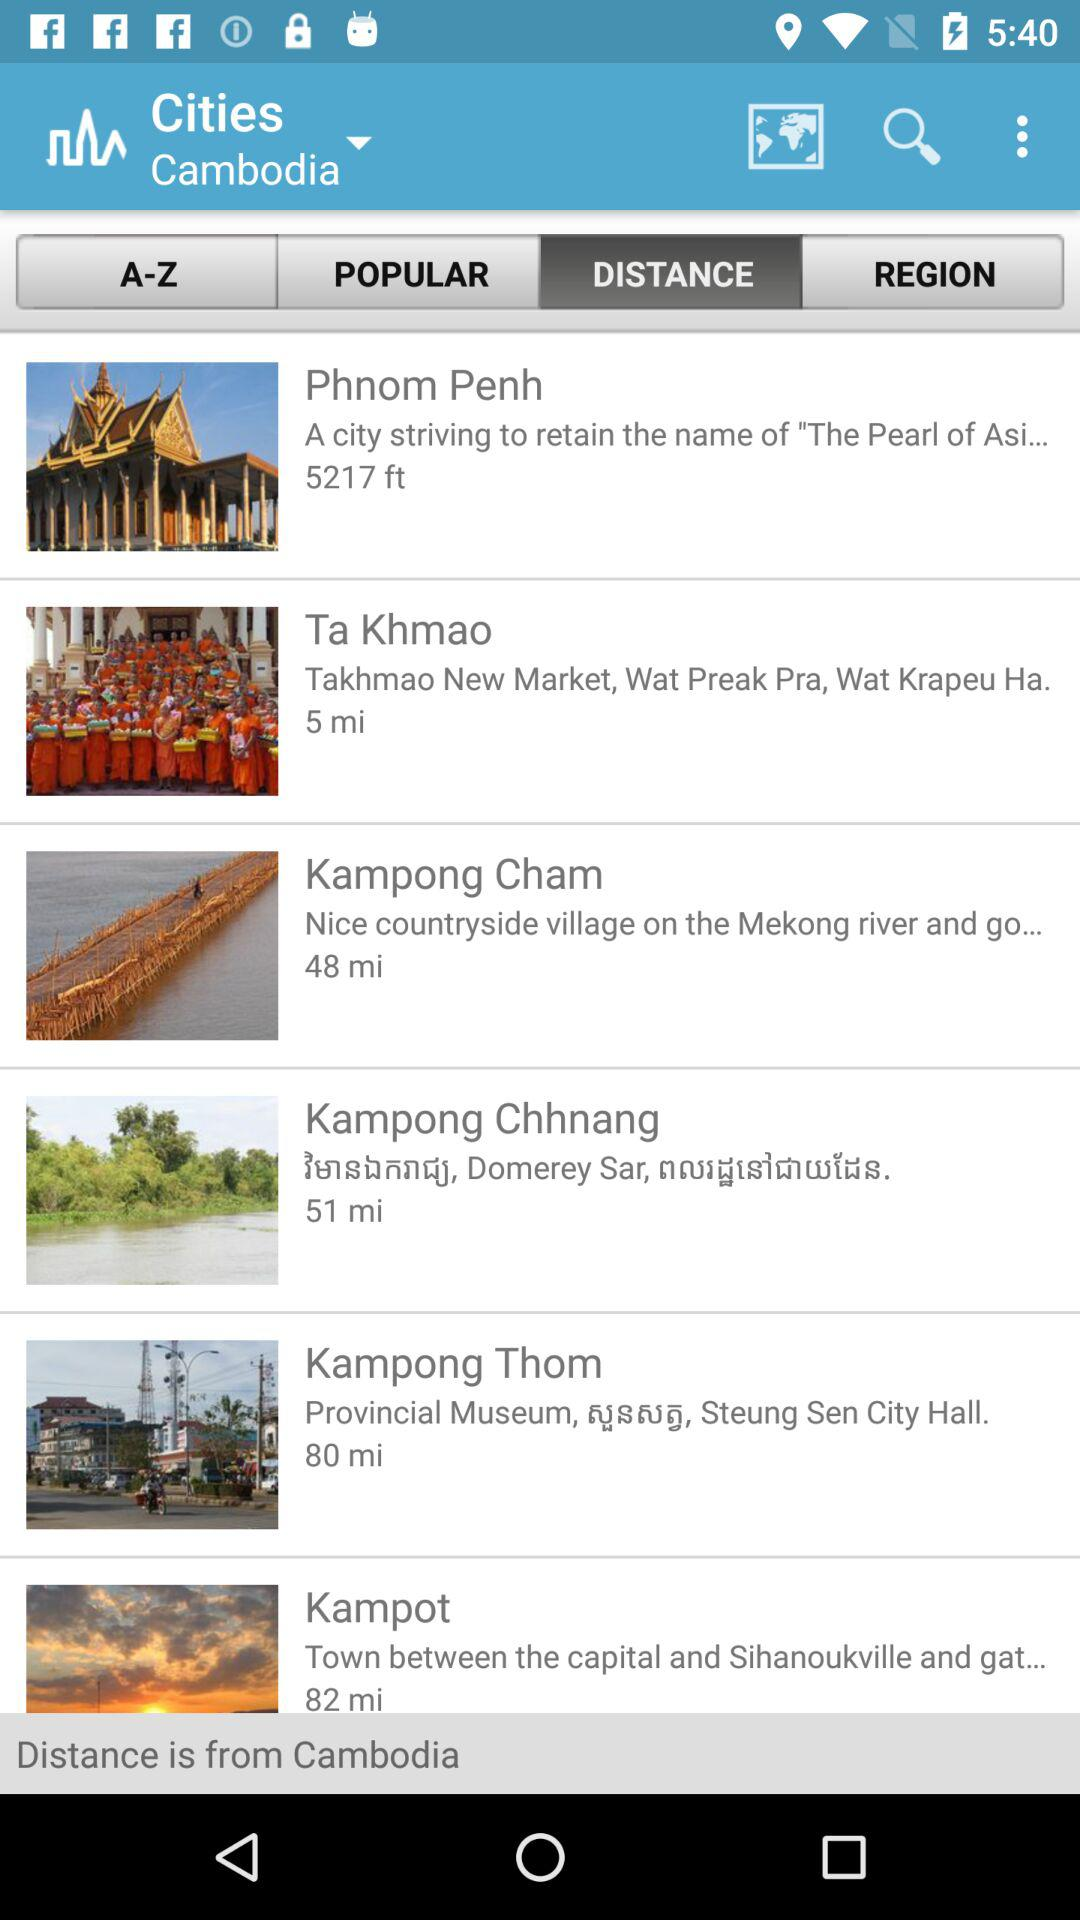What is the distance to Ta Khmao? The distance to Ta Khmao is 5 miles. 